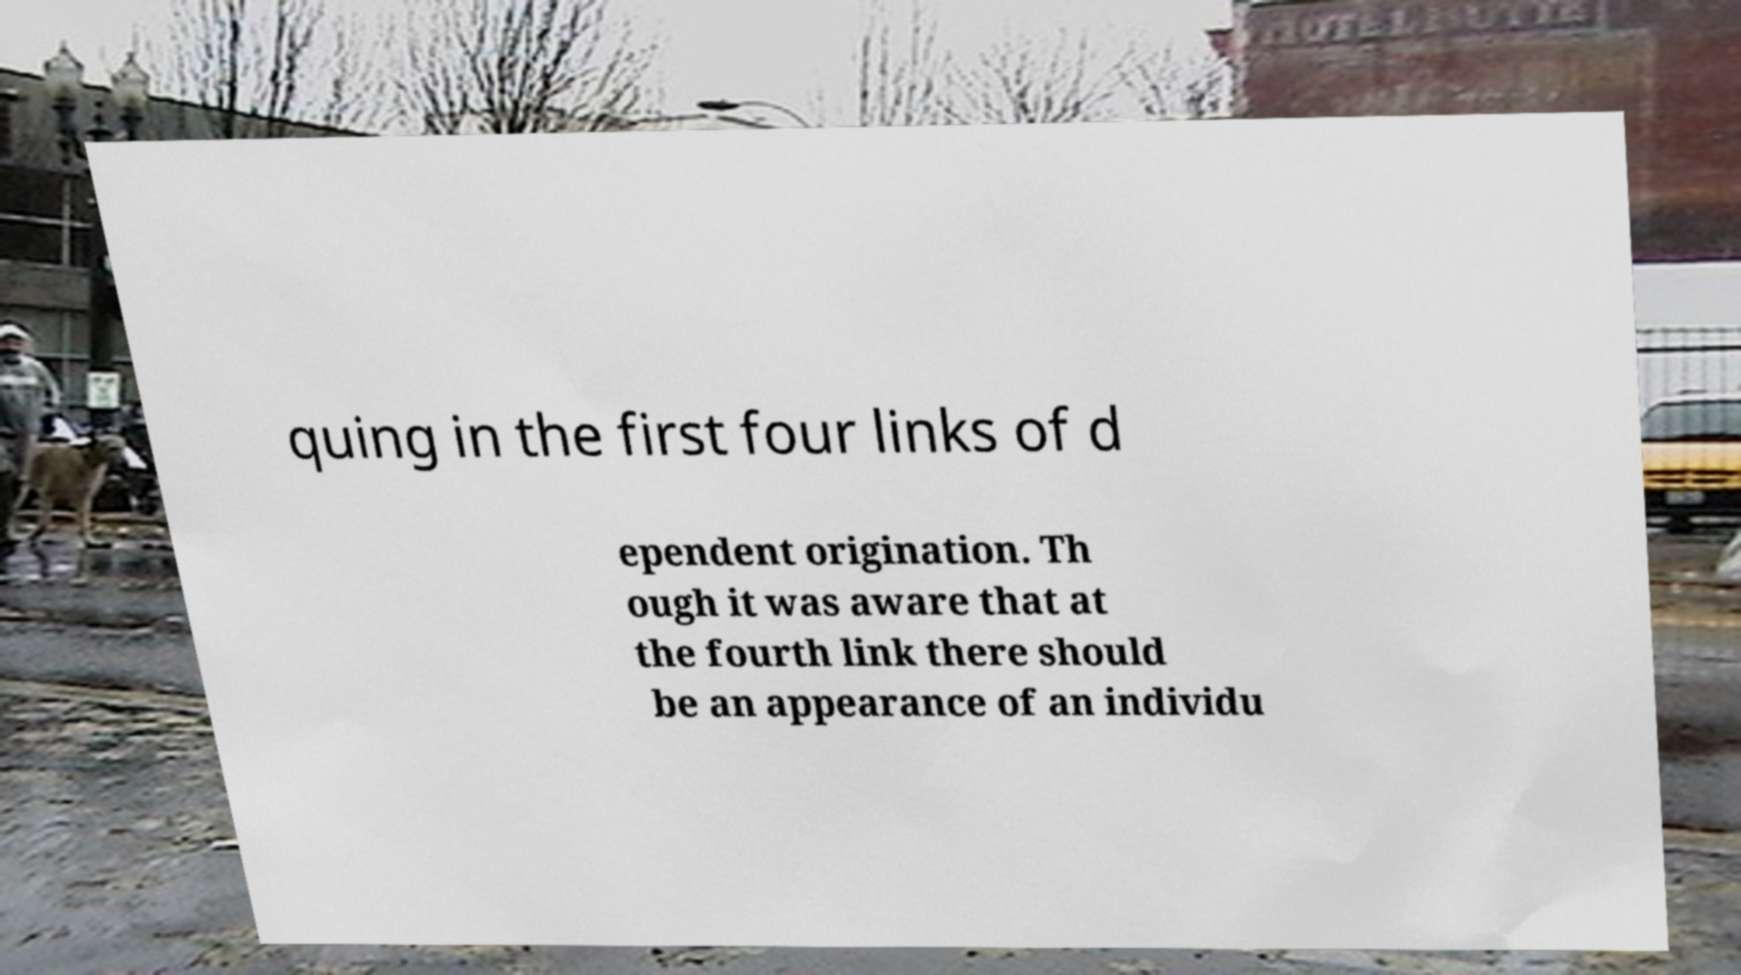Could you extract and type out the text from this image? quing in the first four links of d ependent origination. Th ough it was aware that at the fourth link there should be an appearance of an individu 